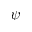<formula> <loc_0><loc_0><loc_500><loc_500>\psi</formula> 